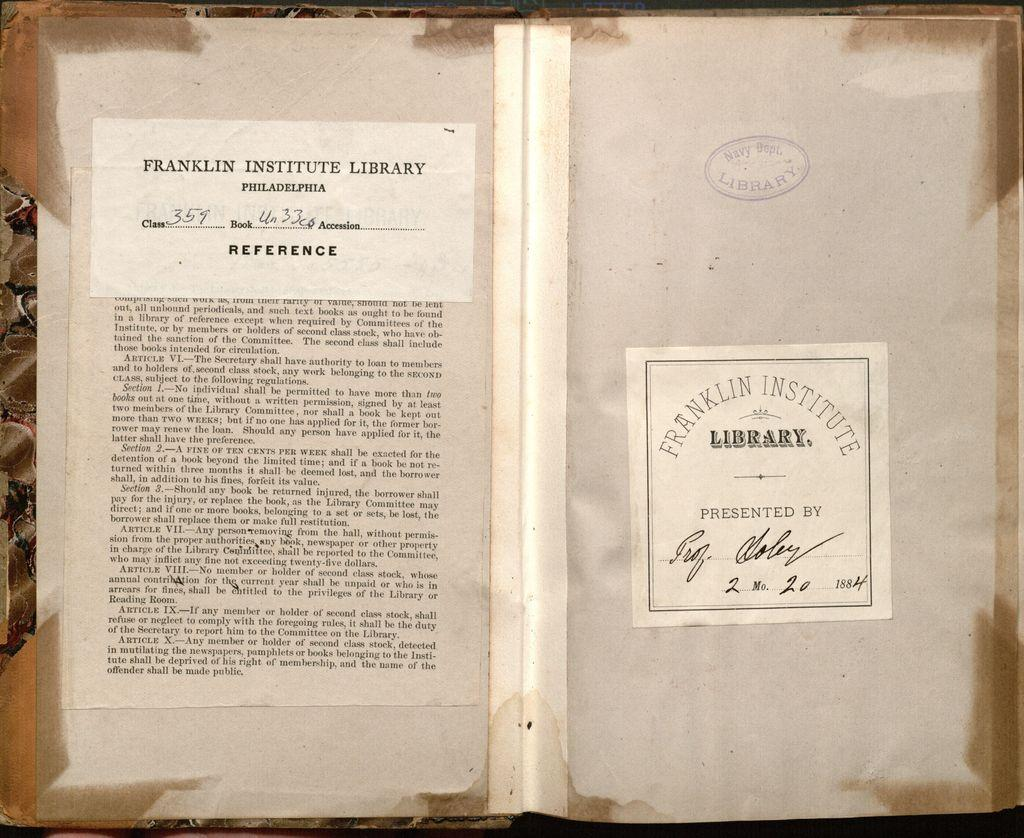What is present on the wall in the image? There is a paper in the image, and it is stuck on a wall. What can be found on the paper? The paper has text on it. How many pots are visible in the image? There are no pots present in the image. What type of hole can be seen in the image? There is no hole present in the image. 